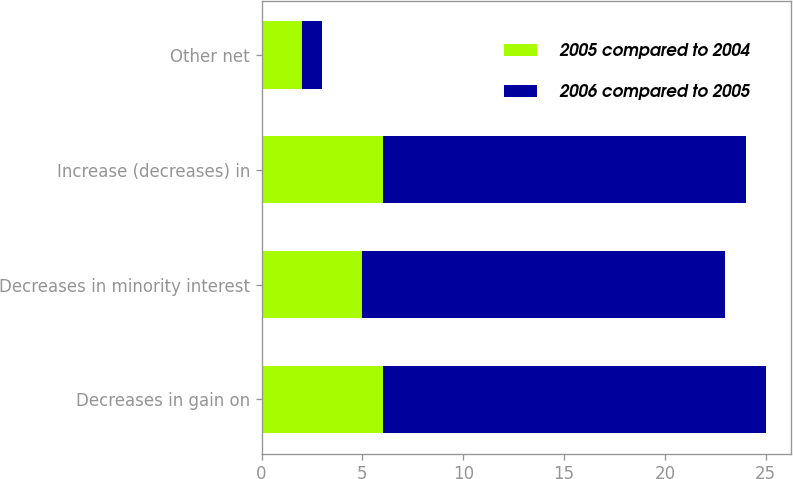Convert chart to OTSL. <chart><loc_0><loc_0><loc_500><loc_500><stacked_bar_chart><ecel><fcel>Decreases in gain on<fcel>Decreases in minority interest<fcel>Increase (decreases) in<fcel>Other net<nl><fcel>2005 compared to 2004<fcel>6<fcel>5<fcel>6<fcel>2<nl><fcel>2006 compared to 2005<fcel>19<fcel>18<fcel>18<fcel>1<nl></chart> 